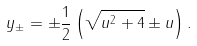<formula> <loc_0><loc_0><loc_500><loc_500>y _ { \pm } = \pm \frac { 1 } { 2 } \left ( \sqrt { u ^ { 2 } + 4 } \pm u \right ) .</formula> 